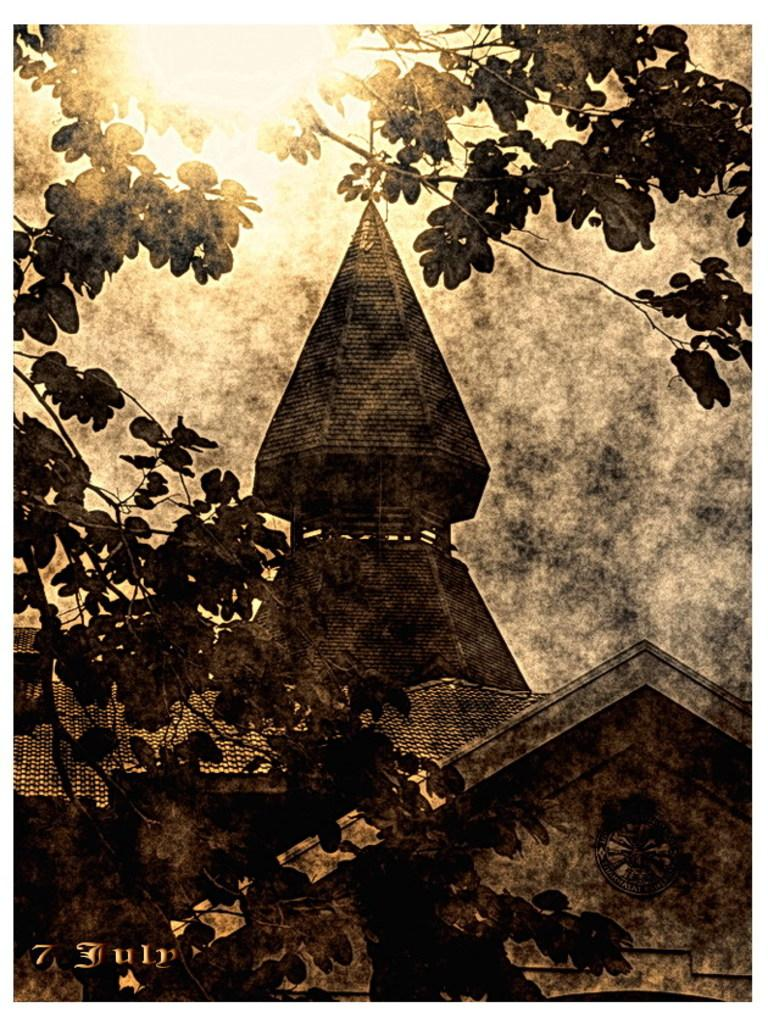What type of image is being described? The image is an edited picture. What can be seen in the foreground of the image? There are stems of a tree in the foreground. What structure is located in the center of the image? There is a building in the center of the image. What is the condition of the sky in the image? The sun is shining at the top of the image. How many slaves are visible in the image? There are no slaves present in the image. What type of cough medicine is being advertised by the actor in the image? There is no actor or cough medicine present in the image. 